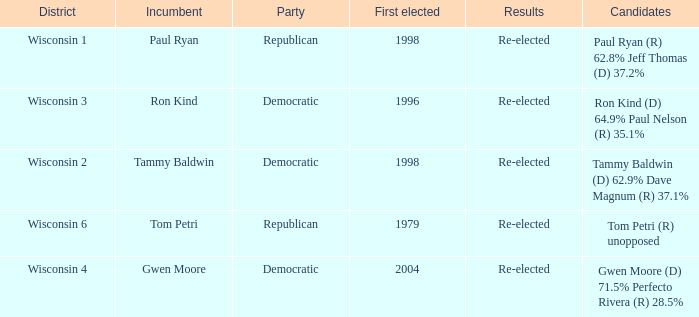What district first elected a Democratic incumbent in 1998? Wisconsin 2. 